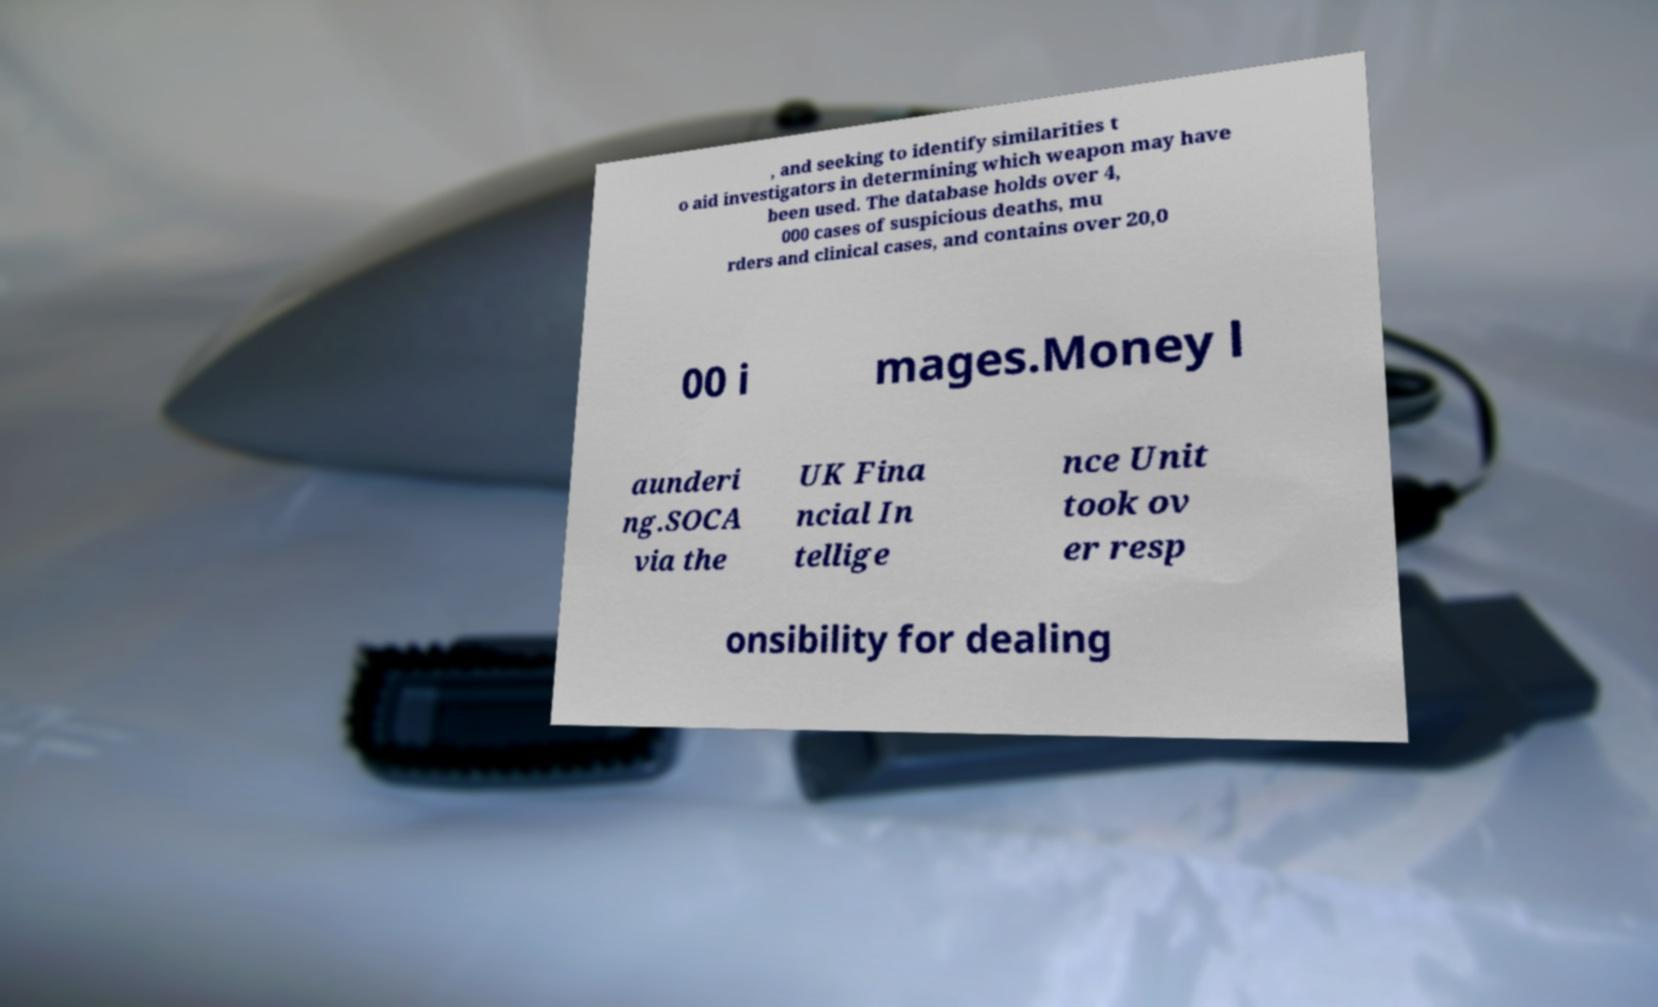For documentation purposes, I need the text within this image transcribed. Could you provide that? , and seeking to identify similarities t o aid investigators in determining which weapon may have been used. The database holds over 4, 000 cases of suspicious deaths, mu rders and clinical cases, and contains over 20,0 00 i mages.Money l aunderi ng.SOCA via the UK Fina ncial In tellige nce Unit took ov er resp onsibility for dealing 